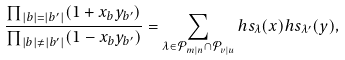Convert formula to latex. <formula><loc_0><loc_0><loc_500><loc_500>\frac { \prod _ { | b | = | b ^ { \prime } | } ( 1 + x _ { b } y _ { b ^ { \prime } } ) } { \prod _ { | b | \neq | b ^ { \prime } | } ( 1 - x _ { b } y _ { b ^ { \prime } } ) } = \sum _ { \lambda \in \mathcal { P } _ { m | n } \cap \mathcal { P } _ { v | u } } h s _ { \lambda } ( x ) h s _ { \lambda ^ { \prime } } ( y ) ,</formula> 